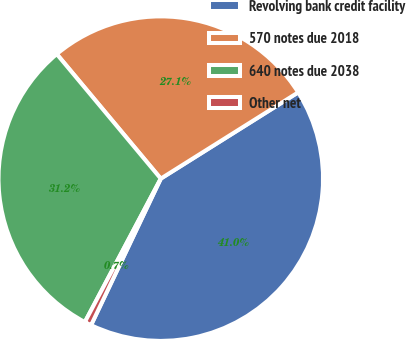Convert chart to OTSL. <chart><loc_0><loc_0><loc_500><loc_500><pie_chart><fcel>Revolving bank credit facility<fcel>570 notes due 2018<fcel>640 notes due 2038<fcel>Other net<nl><fcel>40.99%<fcel>27.15%<fcel>31.18%<fcel>0.68%<nl></chart> 